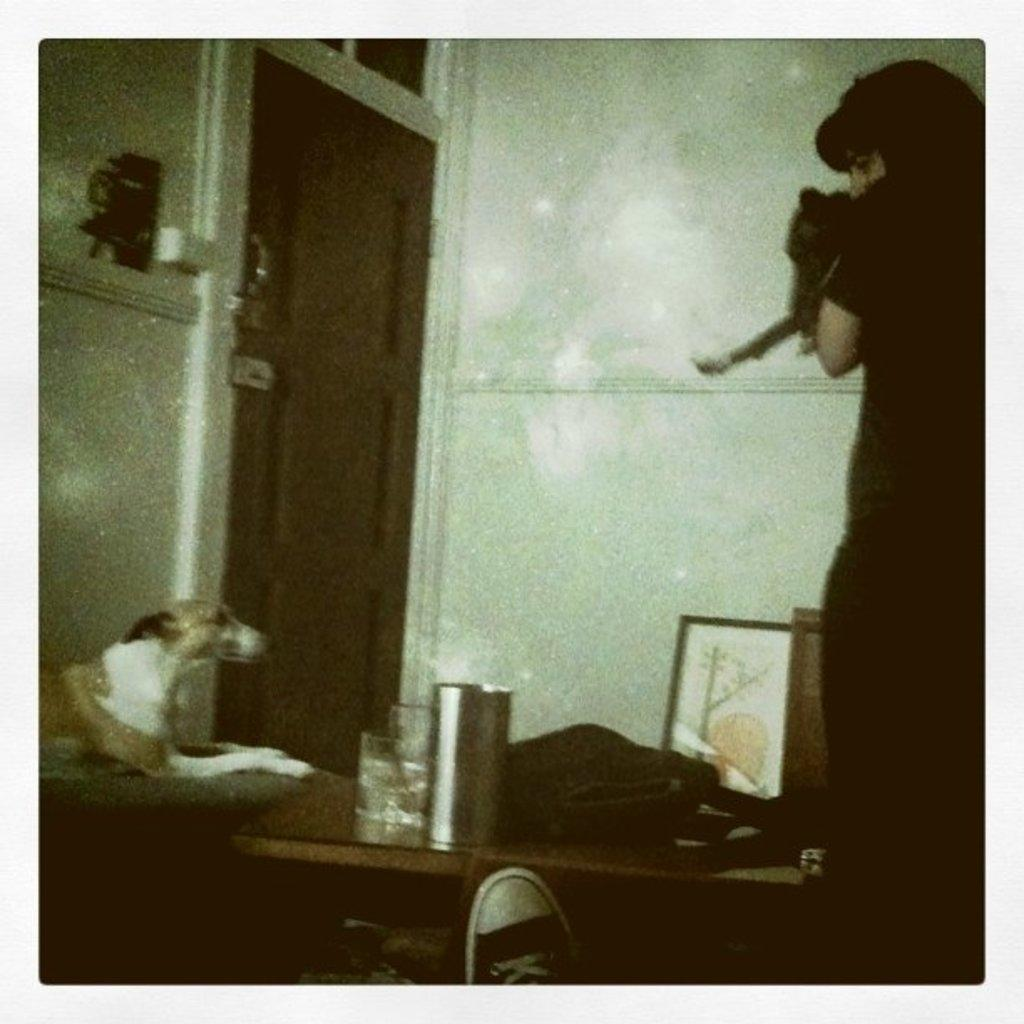Who or what is present in the image? There is a person in the image. What can be seen on the table in the image? There are many objects on a table in the image. Where is the dog located in the image? The dog is on the left side of the image. What is a possible entrance or exit in the image? There is a door in the image. What type of oil is being used to lubricate the bike in the image? There is no bike present in the image, so there is no oil being used to lubricate it. 